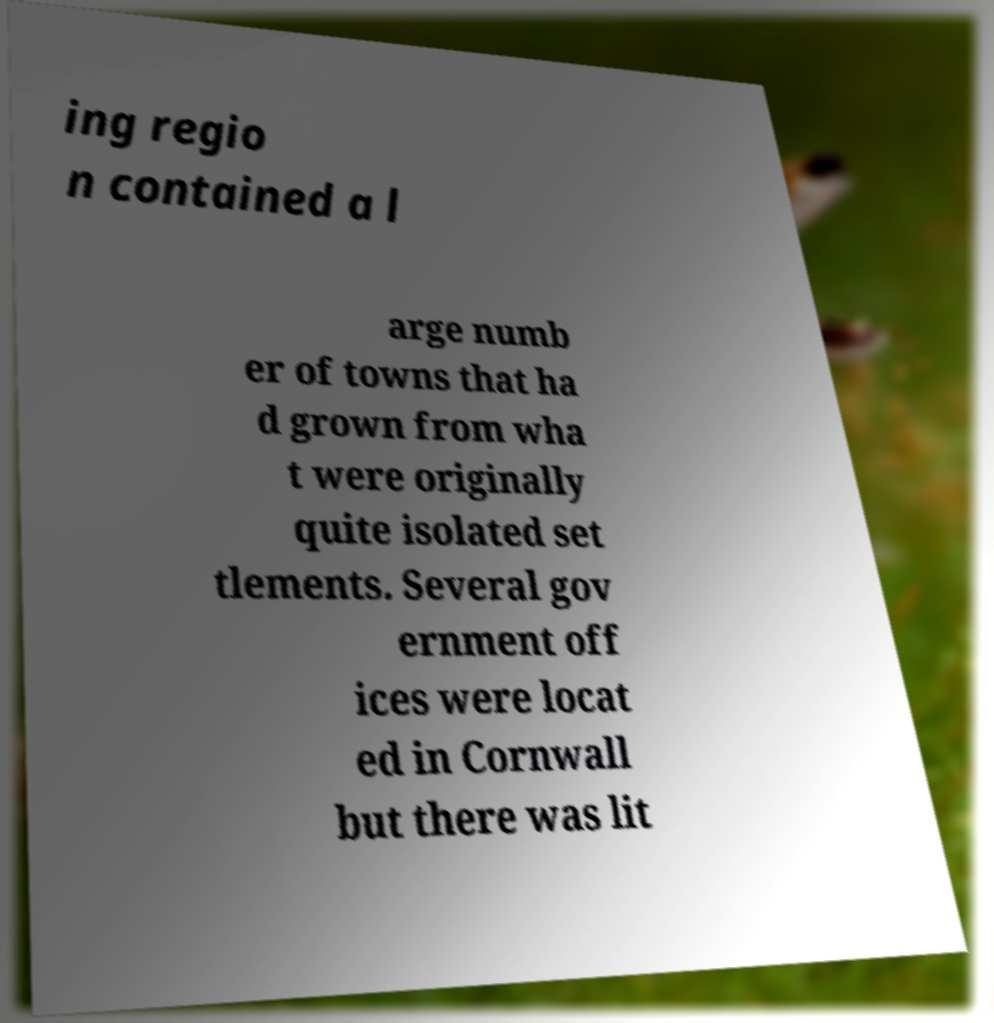Please read and relay the text visible in this image. What does it say? ing regio n contained a l arge numb er of towns that ha d grown from wha t were originally quite isolated set tlements. Several gov ernment off ices were locat ed in Cornwall but there was lit 